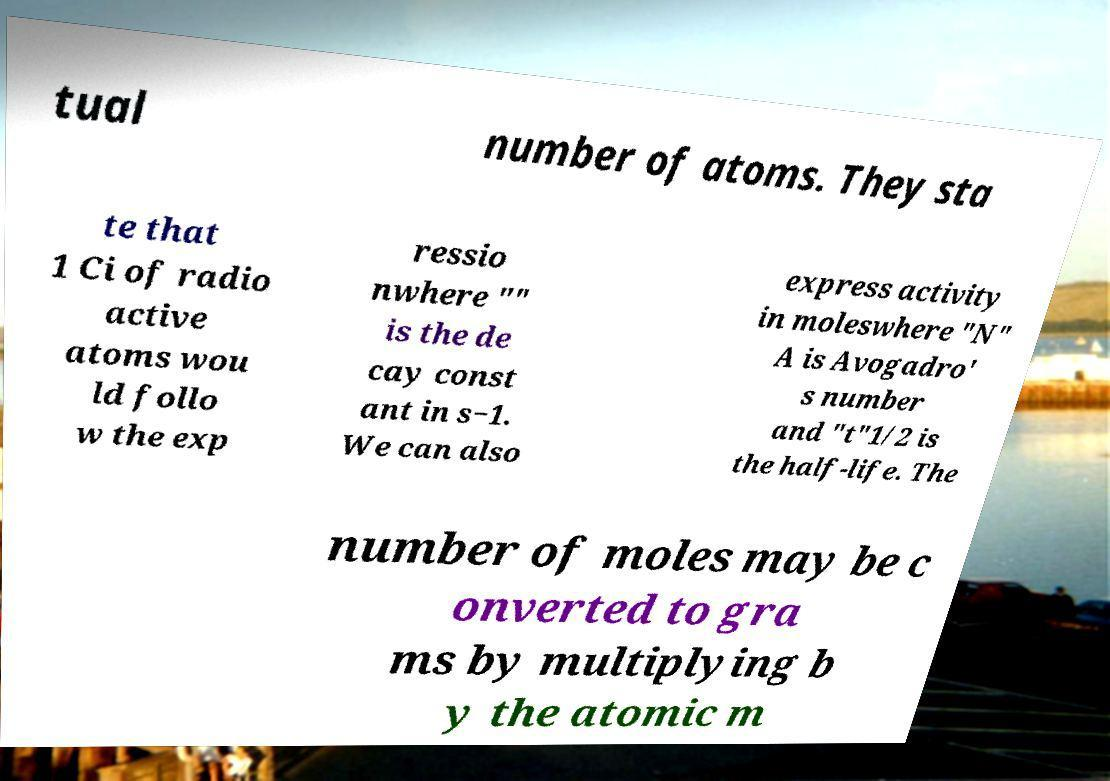What messages or text are displayed in this image? I need them in a readable, typed format. tual number of atoms. They sta te that 1 Ci of radio active atoms wou ld follo w the exp ressio nwhere "" is the de cay const ant in s−1. We can also express activity in moleswhere "N" A is Avogadro' s number and "t"1/2 is the half-life. The number of moles may be c onverted to gra ms by multiplying b y the atomic m 